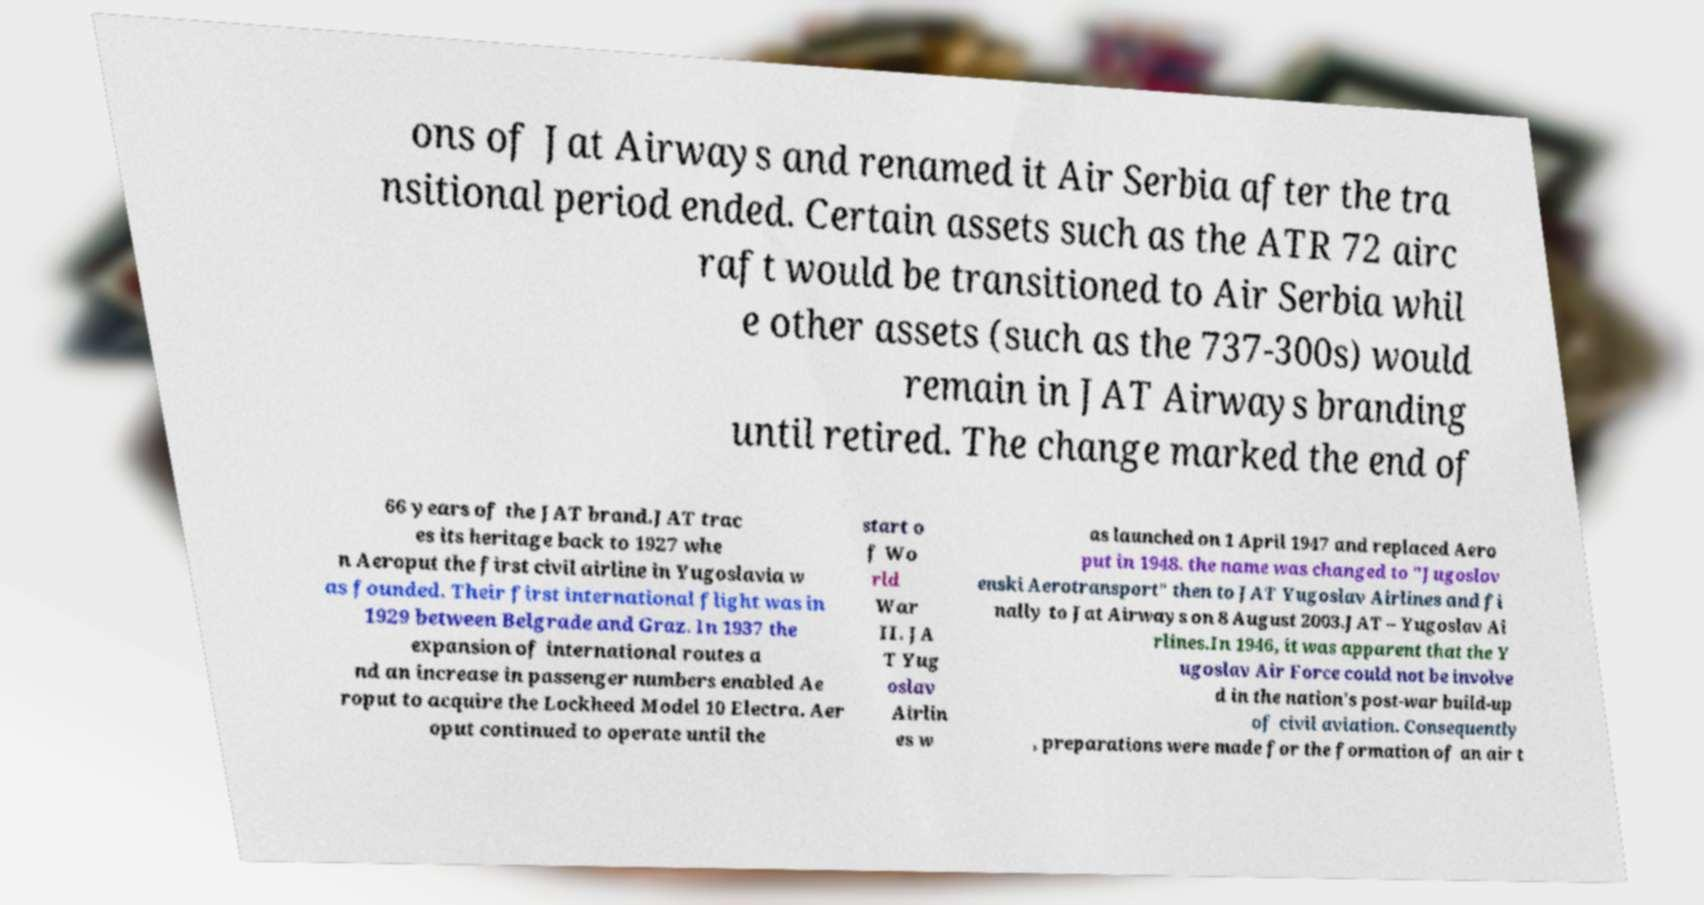There's text embedded in this image that I need extracted. Can you transcribe it verbatim? ons of Jat Airways and renamed it Air Serbia after the tra nsitional period ended. Certain assets such as the ATR 72 airc raft would be transitioned to Air Serbia whil e other assets (such as the 737-300s) would remain in JAT Airways branding until retired. The change marked the end of 66 years of the JAT brand.JAT trac es its heritage back to 1927 whe n Aeroput the first civil airline in Yugoslavia w as founded. Their first international flight was in 1929 between Belgrade and Graz. In 1937 the expansion of international routes a nd an increase in passenger numbers enabled Ae roput to acquire the Lockheed Model 10 Electra. Aer oput continued to operate until the start o f Wo rld War II. JA T Yug oslav Airlin es w as launched on 1 April 1947 and replaced Aero put in 1948. the name was changed to "Jugoslov enski Aerotransport" then to JAT Yugoslav Airlines and fi nally to Jat Airways on 8 August 2003.JAT – Yugoslav Ai rlines.In 1946, it was apparent that the Y ugoslav Air Force could not be involve d in the nation's post-war build-up of civil aviation. Consequently , preparations were made for the formation of an air t 